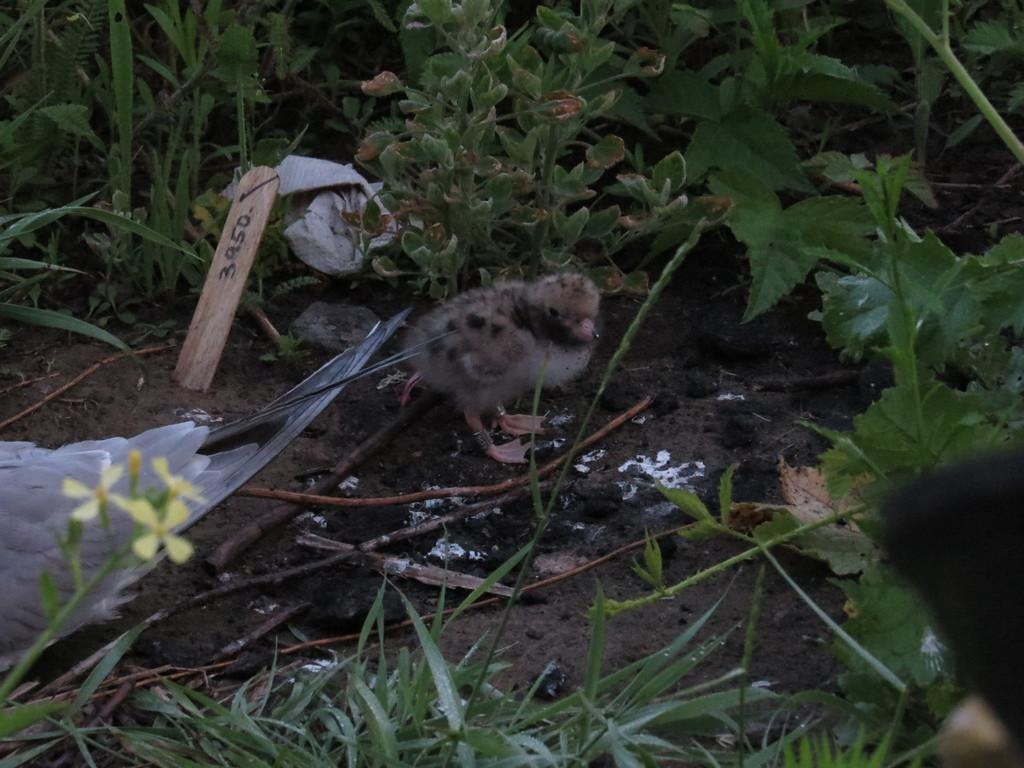What animal can be seen on the ground in the image? There is a chick on the ground in the image. What objects are present in the image besides the chick? There are sticks and plants visible in the image. Where are the white color feathers located in the image? The white color feathers are on the left side of the image. What type of furniture is present in the image? There is no furniture present in the image. What year is depicted in the image? The image does not depict a specific year; it is a snapshot of the current moment. 